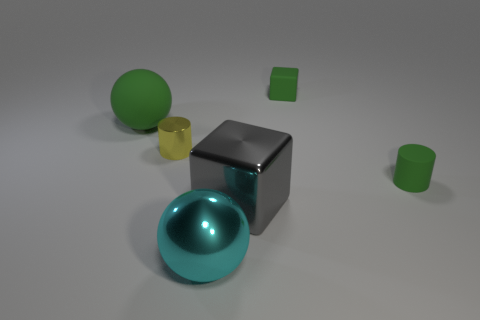What colors are the objects in the image? The objects consist of a green sphere and cubes, a yellow cylinder, a teal sphere, and a gray cube. 